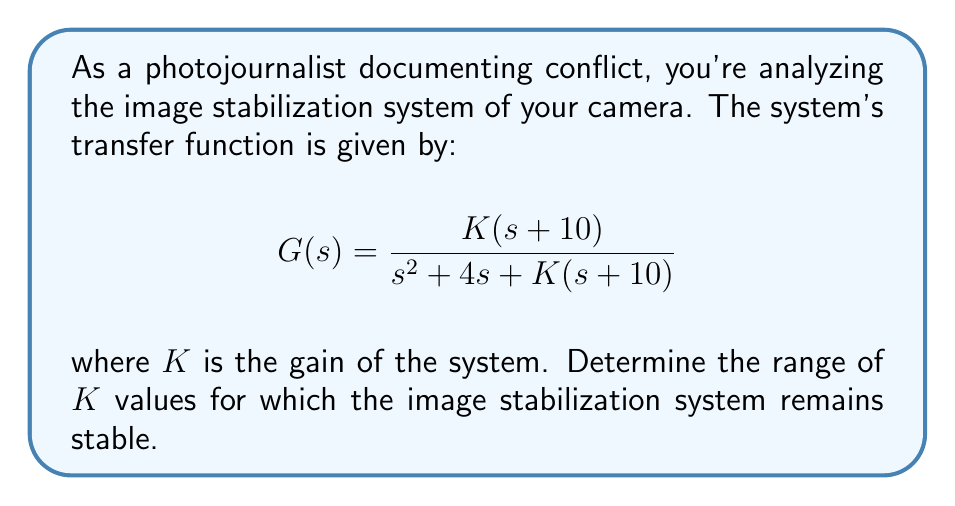What is the answer to this math problem? To evaluate the stability of the system using Laplace transform methods, we'll use the Routh-Hurwitz stability criterion:

1) First, we need to identify the characteristic equation from the transfer function:
   $$s^2 + 4s + K(s+10) = 0$$
   $$s^2 + 4s + Ks + 10K = 0$$

2) Rearrange the equation in descending order of s:
   $$s^2 + (4+K)s + 10K = 0$$

3) Create the Routh array:
   $$\begin{array}{c|c}
   s^2 & 1 & 10K \\
   s^1 & 4+K & 0 \\
   s^0 & 10K & 0
   \end{array}$$

4) For stability, all elements in the first column must be positive:
   
   $1 > 0$ (always true)
   $4+K > 0$
   $10K > 0$

5) From these conditions:
   $K > -4$ and $K > 0$

6) Combining these inequalities:
   $K > 0$

Therefore, the system is stable for all positive values of K.
Answer: $K > 0$ 